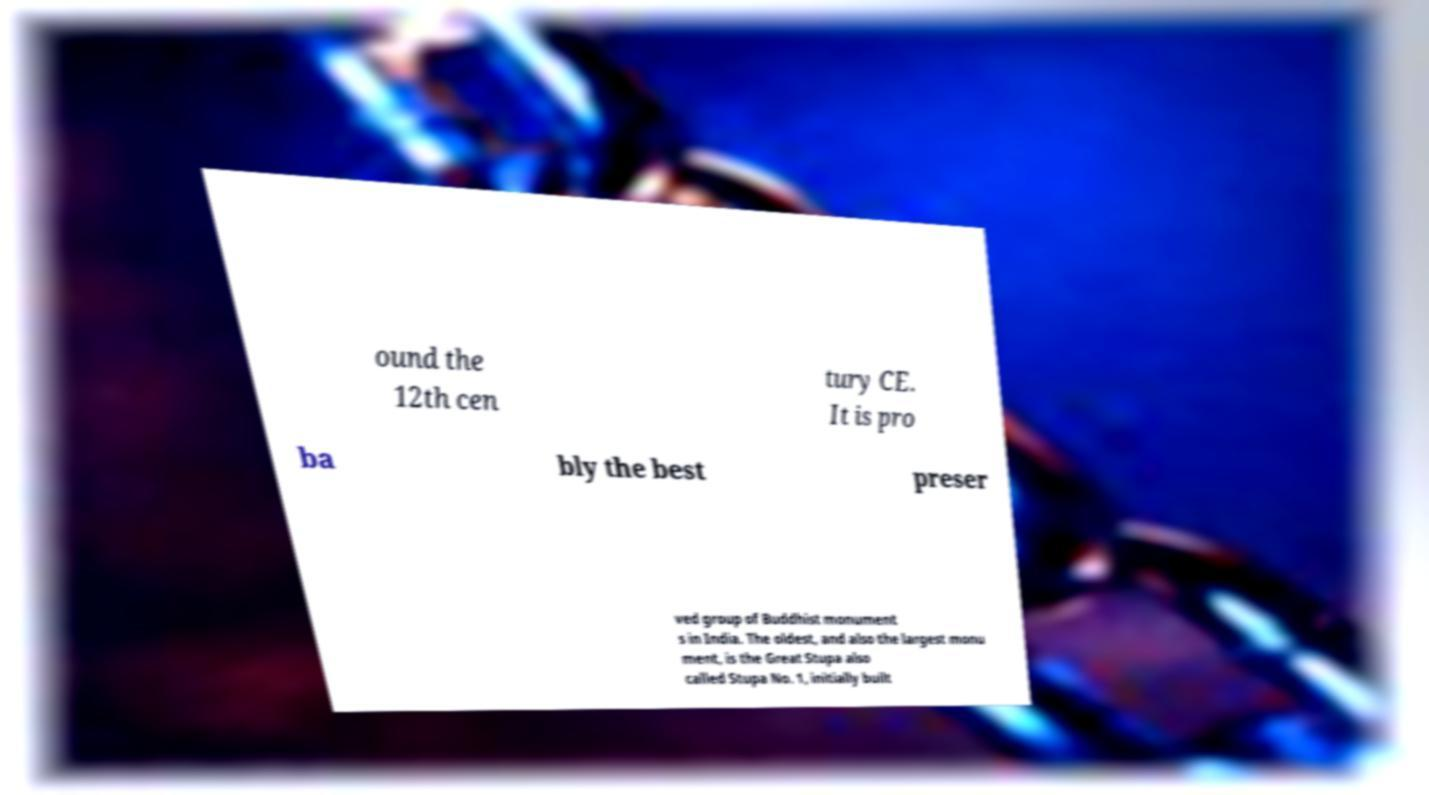Can you accurately transcribe the text from the provided image for me? ound the 12th cen tury CE. It is pro ba bly the best preser ved group of Buddhist monument s in India. The oldest, and also the largest monu ment, is the Great Stupa also called Stupa No. 1, initially built 